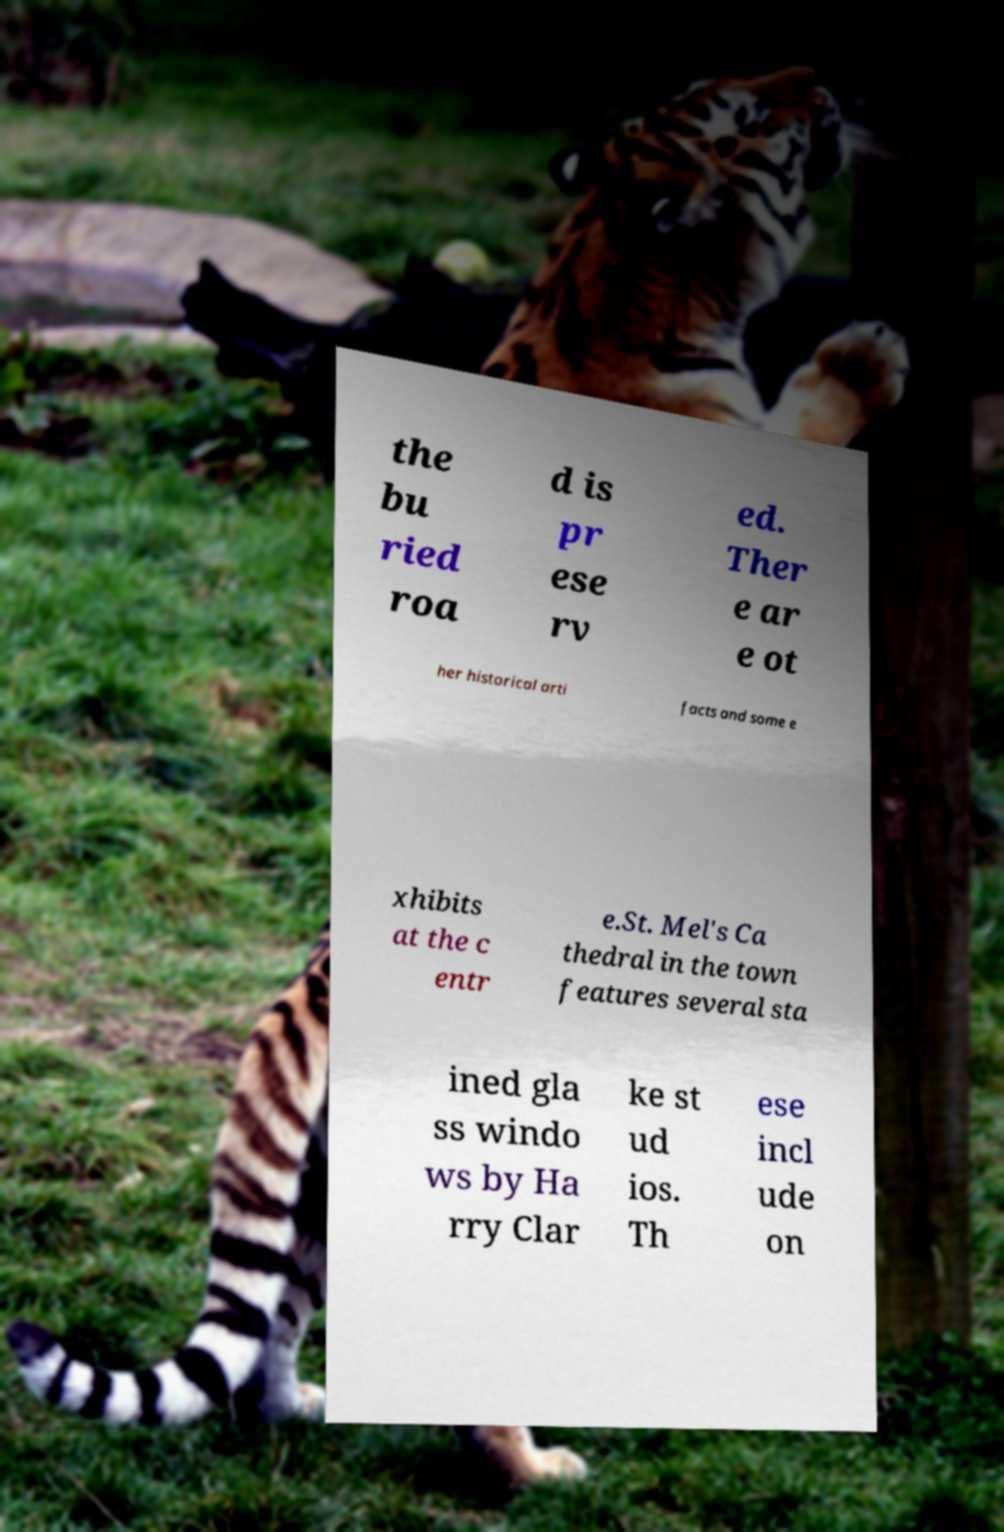Can you read and provide the text displayed in the image?This photo seems to have some interesting text. Can you extract and type it out for me? the bu ried roa d is pr ese rv ed. Ther e ar e ot her historical arti facts and some e xhibits at the c entr e.St. Mel's Ca thedral in the town features several sta ined gla ss windo ws by Ha rry Clar ke st ud ios. Th ese incl ude on 